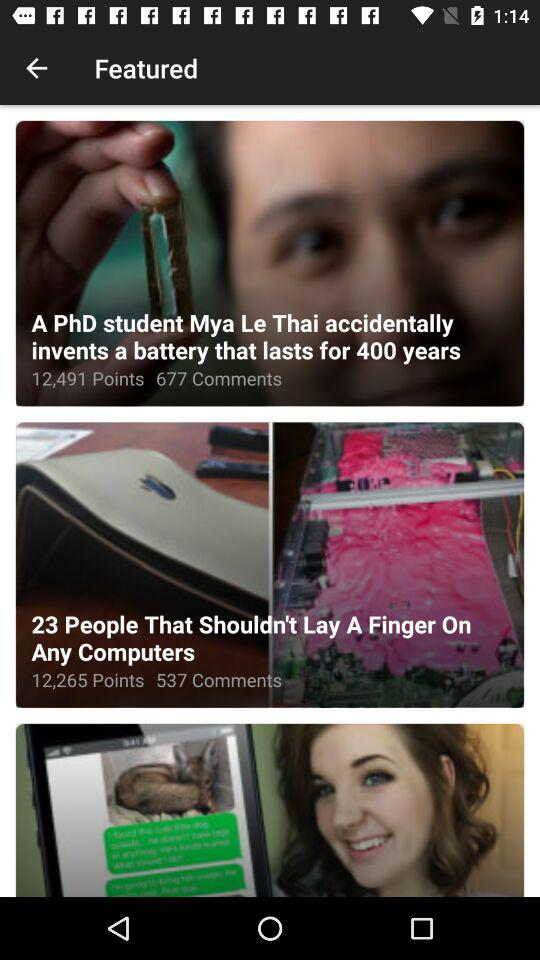How many comments are there for "23 People That Shouldn't Lay A Finger On Any Computers"? There are 537 comments for "23 People That Shouldn't Lay A Finger On Any Computers". 